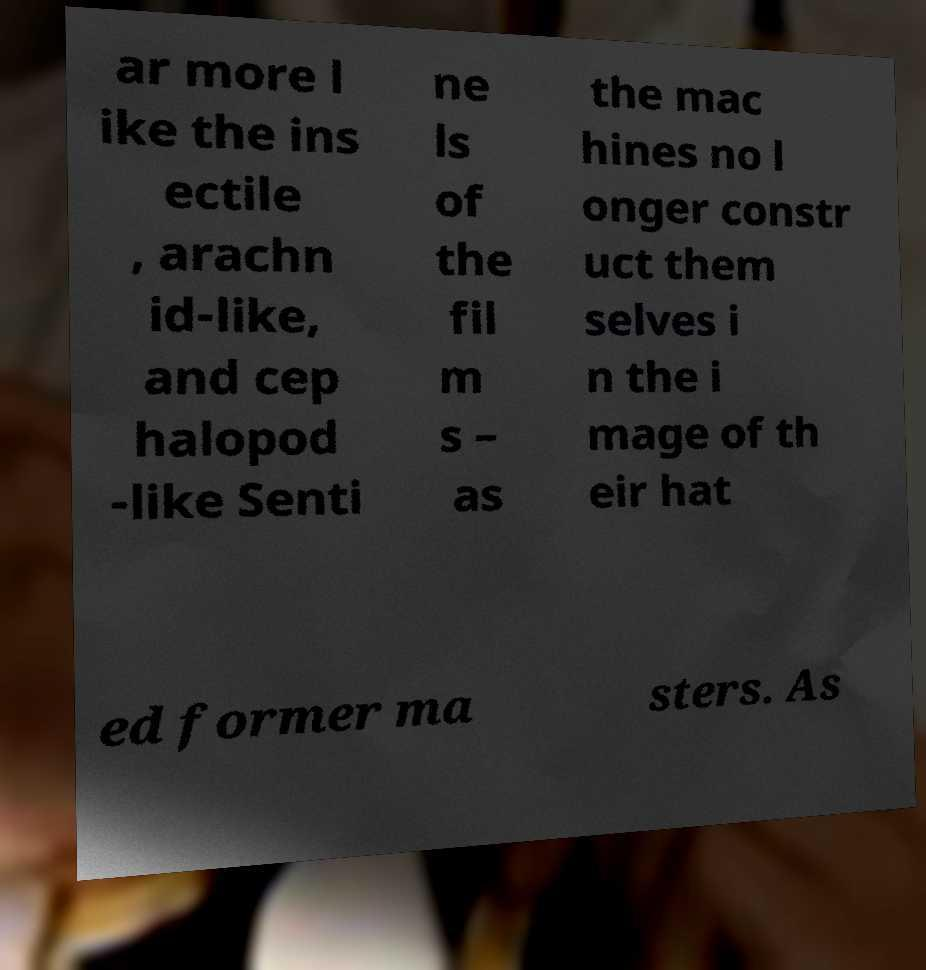Could you assist in decoding the text presented in this image and type it out clearly? ar more l ike the ins ectile , arachn id-like, and cep halopod -like Senti ne ls of the fil m s – as the mac hines no l onger constr uct them selves i n the i mage of th eir hat ed former ma sters. As 